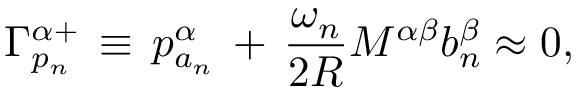<formula> <loc_0><loc_0><loc_500><loc_500>\Gamma _ { p _ { n } } ^ { \alpha + } \, \equiv \, p _ { a _ { n } } ^ { \alpha } \, + \, \frac { \omega _ { n } } { 2 R } M ^ { \alpha \beta } b _ { n } ^ { \beta } \approx 0 , \,</formula> 